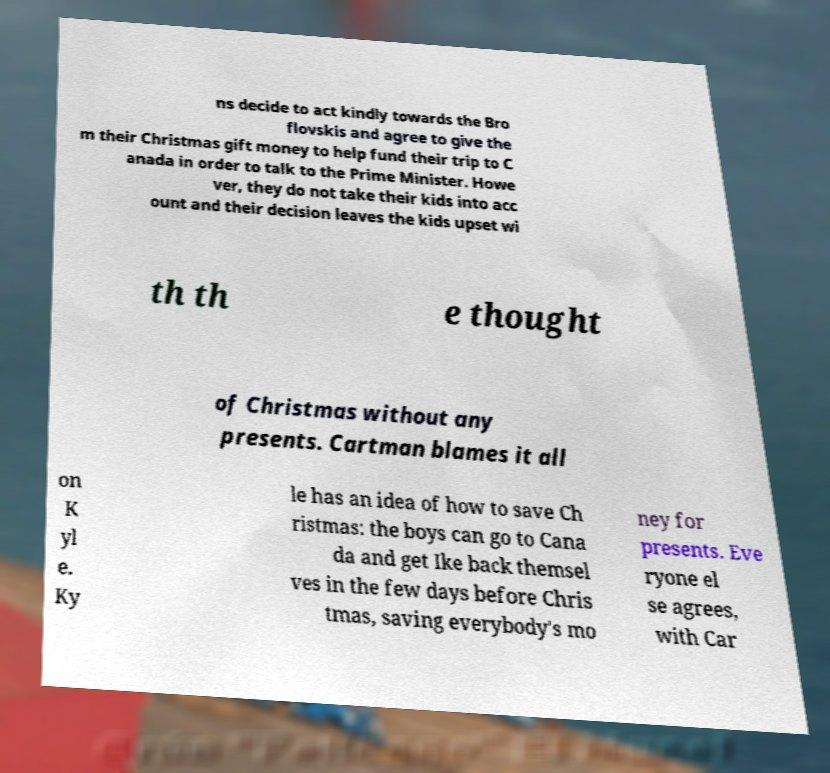Can you read and provide the text displayed in the image?This photo seems to have some interesting text. Can you extract and type it out for me? ns decide to act kindly towards the Bro flovskis and agree to give the m their Christmas gift money to help fund their trip to C anada in order to talk to the Prime Minister. Howe ver, they do not take their kids into acc ount and their decision leaves the kids upset wi th th e thought of Christmas without any presents. Cartman blames it all on K yl e. Ky le has an idea of how to save Ch ristmas: the boys can go to Cana da and get Ike back themsel ves in the few days before Chris tmas, saving everybody's mo ney for presents. Eve ryone el se agrees, with Car 